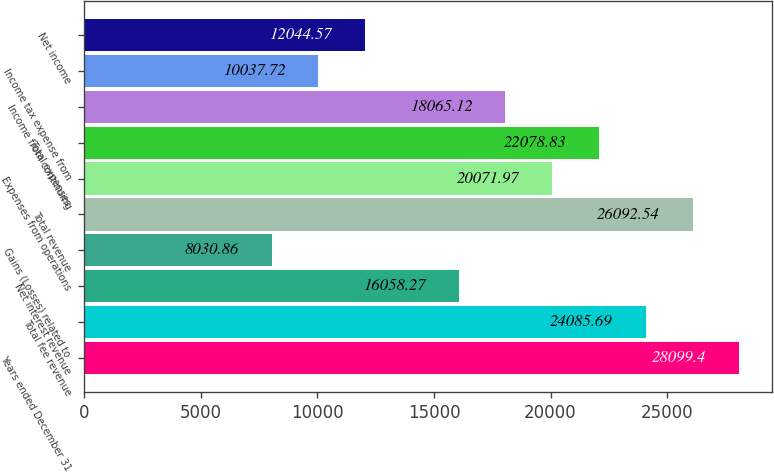<chart> <loc_0><loc_0><loc_500><loc_500><bar_chart><fcel>Years ended December 31<fcel>Total fee revenue<fcel>Net interest revenue<fcel>Gains (Losses) related to<fcel>Total revenue<fcel>Expenses from operations<fcel>Total expenses<fcel>Income from continuing<fcel>Income tax expense from<fcel>Net income<nl><fcel>28099.4<fcel>24085.7<fcel>16058.3<fcel>8030.86<fcel>26092.5<fcel>20072<fcel>22078.8<fcel>18065.1<fcel>10037.7<fcel>12044.6<nl></chart> 